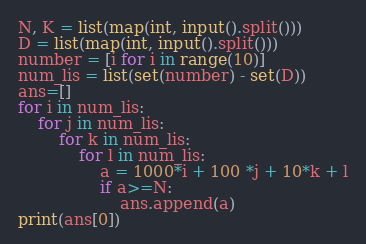Convert code to text. <code><loc_0><loc_0><loc_500><loc_500><_Python_>N, K = list(map(int, input().split()))
D = list(map(int, input().split()))
number = [i for i in range(10)]
num_lis = list(set(number) - set(D))
ans=[]
for i in num_lis:
    for j in num_lis:
        for k in num_lis:
            for l in num_lis:
                a = 1000*i + 100 *j + 10*k + l
                if a>=N:
                    ans.append(a)
print(ans[0])</code> 